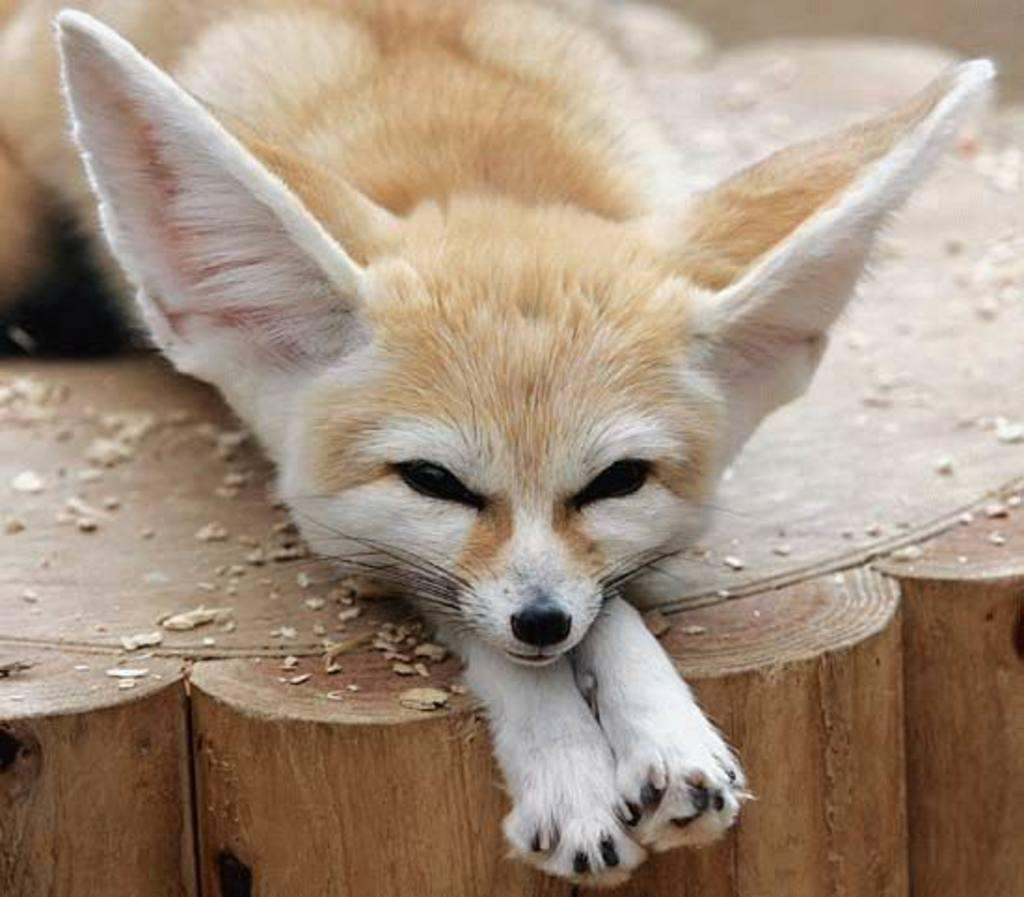What type of animal is in the image? There is a fennec fox in the image. What is the fennec fox standing on? The fennec fox is on a wooden surface. How many times does the fennec fox laugh in the image? The fennec fox does not laugh in the image, as animals do not have the ability to laugh. 